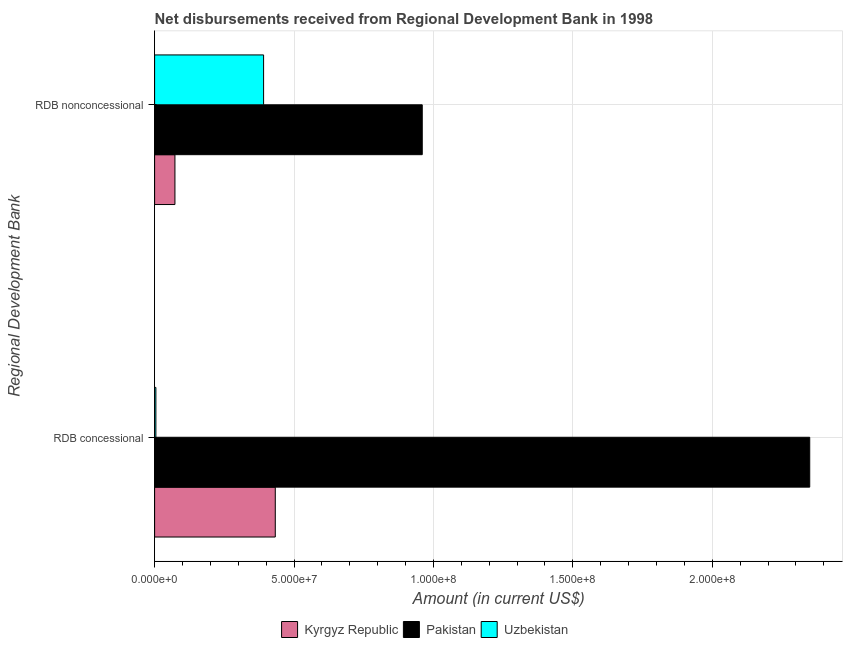Are the number of bars per tick equal to the number of legend labels?
Provide a succinct answer. Yes. What is the label of the 1st group of bars from the top?
Provide a succinct answer. RDB nonconcessional. What is the net concessional disbursements from rdb in Pakistan?
Your response must be concise. 2.35e+08. Across all countries, what is the maximum net concessional disbursements from rdb?
Give a very brief answer. 2.35e+08. Across all countries, what is the minimum net concessional disbursements from rdb?
Offer a very short reply. 4.60e+05. In which country was the net concessional disbursements from rdb maximum?
Your response must be concise. Pakistan. In which country was the net non concessional disbursements from rdb minimum?
Make the answer very short. Kyrgyz Republic. What is the total net concessional disbursements from rdb in the graph?
Give a very brief answer. 2.79e+08. What is the difference between the net concessional disbursements from rdb in Uzbekistan and that in Pakistan?
Your response must be concise. -2.34e+08. What is the difference between the net concessional disbursements from rdb in Kyrgyz Republic and the net non concessional disbursements from rdb in Uzbekistan?
Make the answer very short. 4.19e+06. What is the average net concessional disbursements from rdb per country?
Offer a very short reply. 9.29e+07. What is the difference between the net concessional disbursements from rdb and net non concessional disbursements from rdb in Uzbekistan?
Keep it short and to the point. -3.86e+07. What is the ratio of the net non concessional disbursements from rdb in Kyrgyz Republic to that in Pakistan?
Offer a terse response. 0.08. Is the net concessional disbursements from rdb in Uzbekistan less than that in Kyrgyz Republic?
Give a very brief answer. Yes. What does the 1st bar from the top in RDB concessional represents?
Ensure brevity in your answer.  Uzbekistan. What does the 2nd bar from the bottom in RDB concessional represents?
Offer a terse response. Pakistan. Are all the bars in the graph horizontal?
Provide a succinct answer. Yes. Are the values on the major ticks of X-axis written in scientific E-notation?
Keep it short and to the point. Yes. How many legend labels are there?
Offer a very short reply. 3. How are the legend labels stacked?
Give a very brief answer. Horizontal. What is the title of the graph?
Offer a very short reply. Net disbursements received from Regional Development Bank in 1998. Does "Mozambique" appear as one of the legend labels in the graph?
Give a very brief answer. No. What is the label or title of the Y-axis?
Give a very brief answer. Regional Development Bank. What is the Amount (in current US$) of Kyrgyz Republic in RDB concessional?
Your response must be concise. 4.33e+07. What is the Amount (in current US$) of Pakistan in RDB concessional?
Your answer should be compact. 2.35e+08. What is the Amount (in current US$) of Kyrgyz Republic in RDB nonconcessional?
Your answer should be very brief. 7.29e+06. What is the Amount (in current US$) in Pakistan in RDB nonconcessional?
Your answer should be very brief. 9.60e+07. What is the Amount (in current US$) in Uzbekistan in RDB nonconcessional?
Keep it short and to the point. 3.91e+07. Across all Regional Development Bank, what is the maximum Amount (in current US$) in Kyrgyz Republic?
Your response must be concise. 4.33e+07. Across all Regional Development Bank, what is the maximum Amount (in current US$) in Pakistan?
Provide a succinct answer. 2.35e+08. Across all Regional Development Bank, what is the maximum Amount (in current US$) of Uzbekistan?
Provide a short and direct response. 3.91e+07. Across all Regional Development Bank, what is the minimum Amount (in current US$) in Kyrgyz Republic?
Ensure brevity in your answer.  7.29e+06. Across all Regional Development Bank, what is the minimum Amount (in current US$) in Pakistan?
Provide a short and direct response. 9.60e+07. What is the total Amount (in current US$) in Kyrgyz Republic in the graph?
Provide a succinct answer. 5.06e+07. What is the total Amount (in current US$) in Pakistan in the graph?
Give a very brief answer. 3.31e+08. What is the total Amount (in current US$) of Uzbekistan in the graph?
Provide a short and direct response. 3.95e+07. What is the difference between the Amount (in current US$) in Kyrgyz Republic in RDB concessional and that in RDB nonconcessional?
Provide a short and direct response. 3.60e+07. What is the difference between the Amount (in current US$) of Pakistan in RDB concessional and that in RDB nonconcessional?
Offer a terse response. 1.39e+08. What is the difference between the Amount (in current US$) of Uzbekistan in RDB concessional and that in RDB nonconcessional?
Provide a succinct answer. -3.86e+07. What is the difference between the Amount (in current US$) in Kyrgyz Republic in RDB concessional and the Amount (in current US$) in Pakistan in RDB nonconcessional?
Offer a very short reply. -5.27e+07. What is the difference between the Amount (in current US$) of Kyrgyz Republic in RDB concessional and the Amount (in current US$) of Uzbekistan in RDB nonconcessional?
Your answer should be very brief. 4.19e+06. What is the difference between the Amount (in current US$) of Pakistan in RDB concessional and the Amount (in current US$) of Uzbekistan in RDB nonconcessional?
Provide a short and direct response. 1.96e+08. What is the average Amount (in current US$) of Kyrgyz Republic per Regional Development Bank?
Keep it short and to the point. 2.53e+07. What is the average Amount (in current US$) of Pakistan per Regional Development Bank?
Your answer should be compact. 1.65e+08. What is the average Amount (in current US$) in Uzbekistan per Regional Development Bank?
Offer a terse response. 1.98e+07. What is the difference between the Amount (in current US$) in Kyrgyz Republic and Amount (in current US$) in Pakistan in RDB concessional?
Your response must be concise. -1.92e+08. What is the difference between the Amount (in current US$) in Kyrgyz Republic and Amount (in current US$) in Uzbekistan in RDB concessional?
Offer a terse response. 4.28e+07. What is the difference between the Amount (in current US$) of Pakistan and Amount (in current US$) of Uzbekistan in RDB concessional?
Offer a terse response. 2.34e+08. What is the difference between the Amount (in current US$) in Kyrgyz Republic and Amount (in current US$) in Pakistan in RDB nonconcessional?
Keep it short and to the point. -8.87e+07. What is the difference between the Amount (in current US$) in Kyrgyz Republic and Amount (in current US$) in Uzbekistan in RDB nonconcessional?
Make the answer very short. -3.18e+07. What is the difference between the Amount (in current US$) of Pakistan and Amount (in current US$) of Uzbekistan in RDB nonconcessional?
Offer a very short reply. 5.69e+07. What is the ratio of the Amount (in current US$) in Kyrgyz Republic in RDB concessional to that in RDB nonconcessional?
Make the answer very short. 5.94. What is the ratio of the Amount (in current US$) of Pakistan in RDB concessional to that in RDB nonconcessional?
Your answer should be compact. 2.45. What is the ratio of the Amount (in current US$) of Uzbekistan in RDB concessional to that in RDB nonconcessional?
Offer a very short reply. 0.01. What is the difference between the highest and the second highest Amount (in current US$) in Kyrgyz Republic?
Give a very brief answer. 3.60e+07. What is the difference between the highest and the second highest Amount (in current US$) of Pakistan?
Keep it short and to the point. 1.39e+08. What is the difference between the highest and the second highest Amount (in current US$) in Uzbekistan?
Your answer should be compact. 3.86e+07. What is the difference between the highest and the lowest Amount (in current US$) in Kyrgyz Republic?
Give a very brief answer. 3.60e+07. What is the difference between the highest and the lowest Amount (in current US$) of Pakistan?
Offer a very short reply. 1.39e+08. What is the difference between the highest and the lowest Amount (in current US$) in Uzbekistan?
Offer a very short reply. 3.86e+07. 